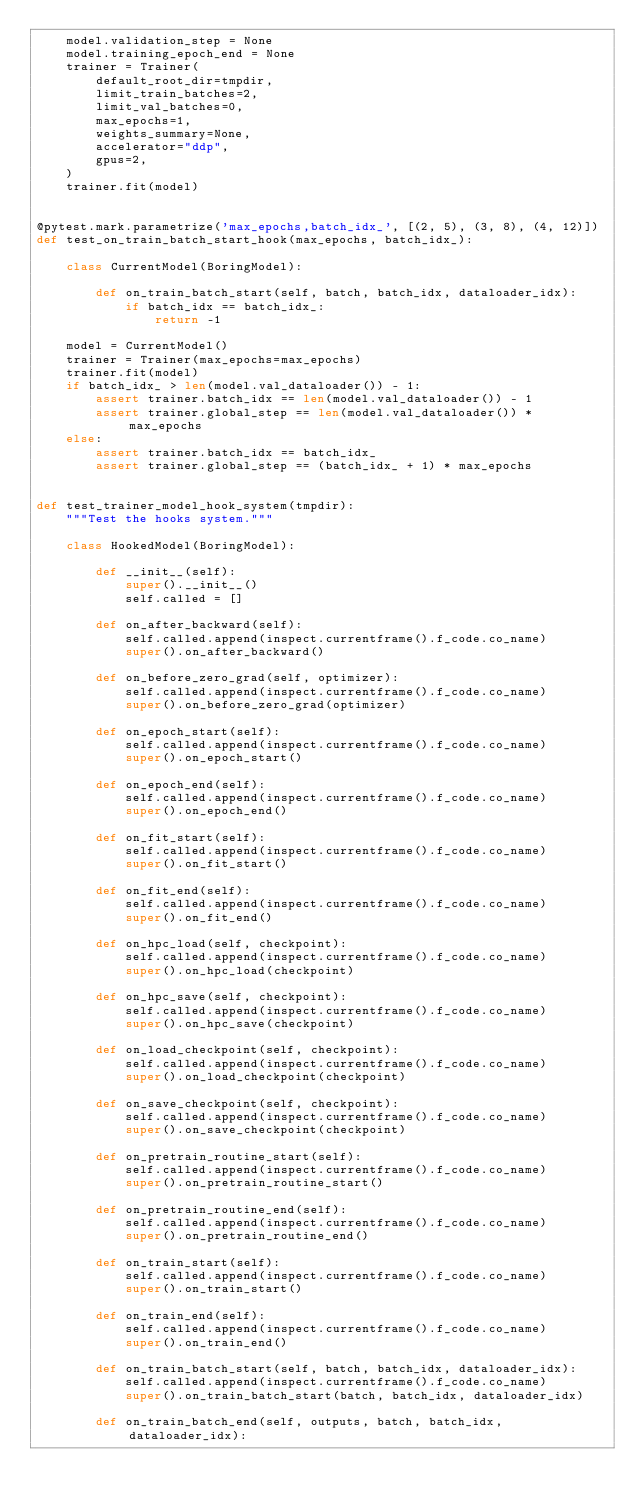Convert code to text. <code><loc_0><loc_0><loc_500><loc_500><_Python_>    model.validation_step = None
    model.training_epoch_end = None
    trainer = Trainer(
        default_root_dir=tmpdir,
        limit_train_batches=2,
        limit_val_batches=0,
        max_epochs=1,
        weights_summary=None,
        accelerator="ddp",
        gpus=2,
    )
    trainer.fit(model)


@pytest.mark.parametrize('max_epochs,batch_idx_', [(2, 5), (3, 8), (4, 12)])
def test_on_train_batch_start_hook(max_epochs, batch_idx_):

    class CurrentModel(BoringModel):

        def on_train_batch_start(self, batch, batch_idx, dataloader_idx):
            if batch_idx == batch_idx_:
                return -1

    model = CurrentModel()
    trainer = Trainer(max_epochs=max_epochs)
    trainer.fit(model)
    if batch_idx_ > len(model.val_dataloader()) - 1:
        assert trainer.batch_idx == len(model.val_dataloader()) - 1
        assert trainer.global_step == len(model.val_dataloader()) * max_epochs
    else:
        assert trainer.batch_idx == batch_idx_
        assert trainer.global_step == (batch_idx_ + 1) * max_epochs


def test_trainer_model_hook_system(tmpdir):
    """Test the hooks system."""

    class HookedModel(BoringModel):

        def __init__(self):
            super().__init__()
            self.called = []

        def on_after_backward(self):
            self.called.append(inspect.currentframe().f_code.co_name)
            super().on_after_backward()

        def on_before_zero_grad(self, optimizer):
            self.called.append(inspect.currentframe().f_code.co_name)
            super().on_before_zero_grad(optimizer)

        def on_epoch_start(self):
            self.called.append(inspect.currentframe().f_code.co_name)
            super().on_epoch_start()

        def on_epoch_end(self):
            self.called.append(inspect.currentframe().f_code.co_name)
            super().on_epoch_end()

        def on_fit_start(self):
            self.called.append(inspect.currentframe().f_code.co_name)
            super().on_fit_start()

        def on_fit_end(self):
            self.called.append(inspect.currentframe().f_code.co_name)
            super().on_fit_end()

        def on_hpc_load(self, checkpoint):
            self.called.append(inspect.currentframe().f_code.co_name)
            super().on_hpc_load(checkpoint)

        def on_hpc_save(self, checkpoint):
            self.called.append(inspect.currentframe().f_code.co_name)
            super().on_hpc_save(checkpoint)

        def on_load_checkpoint(self, checkpoint):
            self.called.append(inspect.currentframe().f_code.co_name)
            super().on_load_checkpoint(checkpoint)

        def on_save_checkpoint(self, checkpoint):
            self.called.append(inspect.currentframe().f_code.co_name)
            super().on_save_checkpoint(checkpoint)

        def on_pretrain_routine_start(self):
            self.called.append(inspect.currentframe().f_code.co_name)
            super().on_pretrain_routine_start()

        def on_pretrain_routine_end(self):
            self.called.append(inspect.currentframe().f_code.co_name)
            super().on_pretrain_routine_end()

        def on_train_start(self):
            self.called.append(inspect.currentframe().f_code.co_name)
            super().on_train_start()

        def on_train_end(self):
            self.called.append(inspect.currentframe().f_code.co_name)
            super().on_train_end()

        def on_train_batch_start(self, batch, batch_idx, dataloader_idx):
            self.called.append(inspect.currentframe().f_code.co_name)
            super().on_train_batch_start(batch, batch_idx, dataloader_idx)

        def on_train_batch_end(self, outputs, batch, batch_idx, dataloader_idx):</code> 